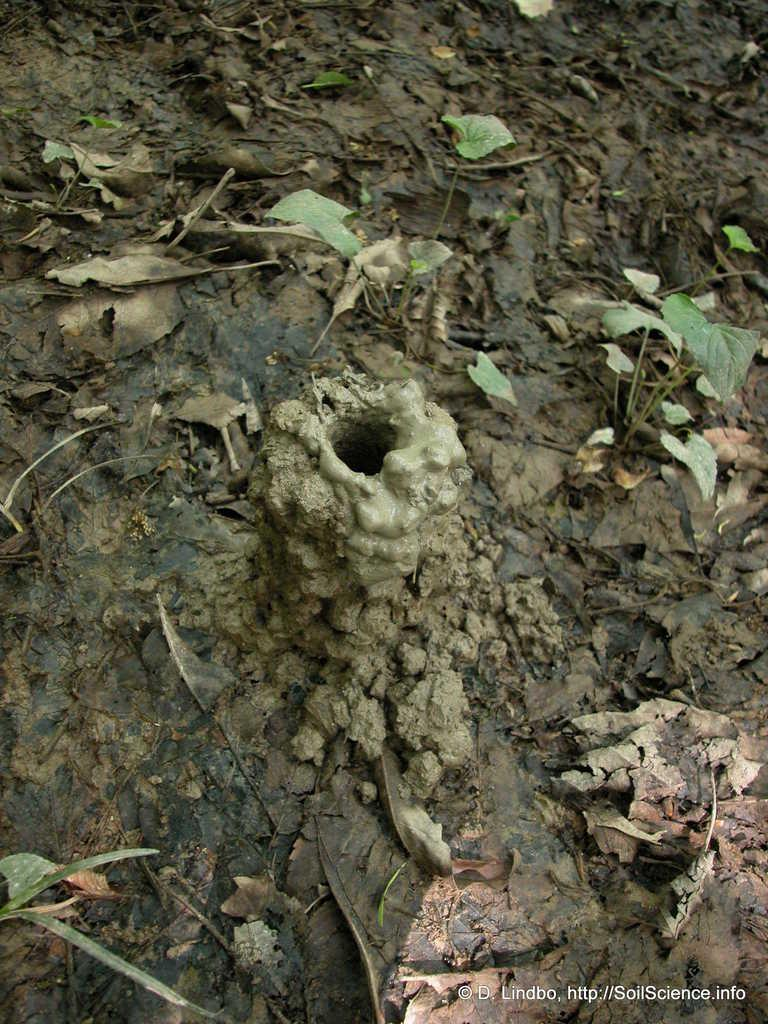What type of living organisms can be seen in the image? Plants and leaves are visible in the image. What is the texture of the soil in the image? The soil appears to be clay-like in the image. Is there any text or marking in the image? Yes, there is a watermark in the bottom right corner of the image. What flavor of ice cream is being advertised in the image? There is no ice cream or advertisement present in the image; it features plants and leaves. What is the cause of death for the plant in the image? There is no indication of a dead plant in the image, and the cause of death cannot be determined from the image. 